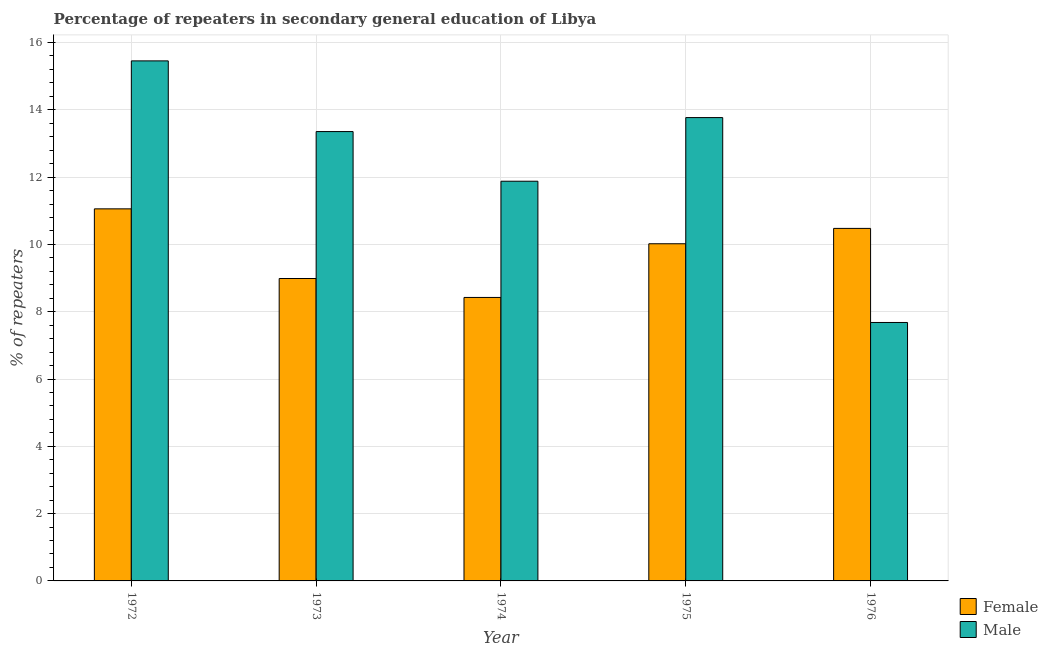Are the number of bars per tick equal to the number of legend labels?
Provide a succinct answer. Yes. Are the number of bars on each tick of the X-axis equal?
Offer a very short reply. Yes. How many bars are there on the 1st tick from the left?
Offer a very short reply. 2. How many bars are there on the 4th tick from the right?
Your answer should be compact. 2. What is the label of the 1st group of bars from the left?
Provide a short and direct response. 1972. What is the percentage of female repeaters in 1974?
Your answer should be compact. 8.42. Across all years, what is the maximum percentage of male repeaters?
Offer a very short reply. 15.45. Across all years, what is the minimum percentage of male repeaters?
Provide a short and direct response. 7.68. In which year was the percentage of male repeaters minimum?
Offer a terse response. 1976. What is the total percentage of male repeaters in the graph?
Keep it short and to the point. 62.13. What is the difference between the percentage of male repeaters in 1973 and that in 1974?
Make the answer very short. 1.48. What is the difference between the percentage of female repeaters in 1974 and the percentage of male repeaters in 1976?
Your answer should be compact. -2.05. What is the average percentage of female repeaters per year?
Your response must be concise. 9.79. In how many years, is the percentage of female repeaters greater than 12 %?
Offer a terse response. 0. What is the ratio of the percentage of female repeaters in 1973 to that in 1976?
Make the answer very short. 0.86. Is the percentage of male repeaters in 1973 less than that in 1976?
Provide a succinct answer. No. What is the difference between the highest and the second highest percentage of male repeaters?
Your response must be concise. 1.68. What is the difference between the highest and the lowest percentage of female repeaters?
Provide a short and direct response. 2.63. What does the 2nd bar from the right in 1975 represents?
Provide a succinct answer. Female. How many legend labels are there?
Give a very brief answer. 2. How are the legend labels stacked?
Provide a succinct answer. Vertical. What is the title of the graph?
Your answer should be compact. Percentage of repeaters in secondary general education of Libya. Does "GDP per capita" appear as one of the legend labels in the graph?
Your response must be concise. No. What is the label or title of the X-axis?
Make the answer very short. Year. What is the label or title of the Y-axis?
Your response must be concise. % of repeaters. What is the % of repeaters in Female in 1972?
Your answer should be very brief. 11.06. What is the % of repeaters of Male in 1972?
Give a very brief answer. 15.45. What is the % of repeaters in Female in 1973?
Offer a very short reply. 8.99. What is the % of repeaters in Male in 1973?
Ensure brevity in your answer.  13.35. What is the % of repeaters of Female in 1974?
Keep it short and to the point. 8.42. What is the % of repeaters in Male in 1974?
Your answer should be compact. 11.88. What is the % of repeaters of Female in 1975?
Provide a short and direct response. 10.02. What is the % of repeaters of Male in 1975?
Provide a succinct answer. 13.77. What is the % of repeaters in Female in 1976?
Provide a short and direct response. 10.48. What is the % of repeaters in Male in 1976?
Your response must be concise. 7.68. Across all years, what is the maximum % of repeaters in Female?
Make the answer very short. 11.06. Across all years, what is the maximum % of repeaters in Male?
Ensure brevity in your answer.  15.45. Across all years, what is the minimum % of repeaters of Female?
Provide a short and direct response. 8.42. Across all years, what is the minimum % of repeaters in Male?
Ensure brevity in your answer.  7.68. What is the total % of repeaters in Female in the graph?
Your answer should be very brief. 48.96. What is the total % of repeaters of Male in the graph?
Your answer should be compact. 62.13. What is the difference between the % of repeaters in Female in 1972 and that in 1973?
Ensure brevity in your answer.  2.07. What is the difference between the % of repeaters in Male in 1972 and that in 1973?
Give a very brief answer. 2.1. What is the difference between the % of repeaters in Female in 1972 and that in 1974?
Provide a short and direct response. 2.63. What is the difference between the % of repeaters of Male in 1972 and that in 1974?
Make the answer very short. 3.58. What is the difference between the % of repeaters in Female in 1972 and that in 1975?
Provide a short and direct response. 1.04. What is the difference between the % of repeaters of Male in 1972 and that in 1975?
Ensure brevity in your answer.  1.68. What is the difference between the % of repeaters in Female in 1972 and that in 1976?
Your answer should be very brief. 0.58. What is the difference between the % of repeaters of Male in 1972 and that in 1976?
Your response must be concise. 7.77. What is the difference between the % of repeaters in Female in 1973 and that in 1974?
Offer a very short reply. 0.56. What is the difference between the % of repeaters in Male in 1973 and that in 1974?
Offer a terse response. 1.48. What is the difference between the % of repeaters of Female in 1973 and that in 1975?
Make the answer very short. -1.03. What is the difference between the % of repeaters of Male in 1973 and that in 1975?
Your answer should be very brief. -0.42. What is the difference between the % of repeaters of Female in 1973 and that in 1976?
Your response must be concise. -1.49. What is the difference between the % of repeaters in Male in 1973 and that in 1976?
Your answer should be very brief. 5.67. What is the difference between the % of repeaters of Female in 1974 and that in 1975?
Make the answer very short. -1.6. What is the difference between the % of repeaters of Male in 1974 and that in 1975?
Offer a terse response. -1.89. What is the difference between the % of repeaters in Female in 1974 and that in 1976?
Ensure brevity in your answer.  -2.05. What is the difference between the % of repeaters of Male in 1974 and that in 1976?
Your answer should be very brief. 4.2. What is the difference between the % of repeaters of Female in 1975 and that in 1976?
Ensure brevity in your answer.  -0.46. What is the difference between the % of repeaters of Male in 1975 and that in 1976?
Your answer should be very brief. 6.09. What is the difference between the % of repeaters of Female in 1972 and the % of repeaters of Male in 1973?
Your answer should be very brief. -2.3. What is the difference between the % of repeaters in Female in 1972 and the % of repeaters in Male in 1974?
Ensure brevity in your answer.  -0.82. What is the difference between the % of repeaters in Female in 1972 and the % of repeaters in Male in 1975?
Offer a terse response. -2.71. What is the difference between the % of repeaters in Female in 1972 and the % of repeaters in Male in 1976?
Offer a terse response. 3.38. What is the difference between the % of repeaters of Female in 1973 and the % of repeaters of Male in 1974?
Provide a short and direct response. -2.89. What is the difference between the % of repeaters of Female in 1973 and the % of repeaters of Male in 1975?
Offer a very short reply. -4.78. What is the difference between the % of repeaters of Female in 1973 and the % of repeaters of Male in 1976?
Keep it short and to the point. 1.31. What is the difference between the % of repeaters of Female in 1974 and the % of repeaters of Male in 1975?
Your response must be concise. -5.34. What is the difference between the % of repeaters in Female in 1974 and the % of repeaters in Male in 1976?
Keep it short and to the point. 0.74. What is the difference between the % of repeaters in Female in 1975 and the % of repeaters in Male in 1976?
Offer a very short reply. 2.34. What is the average % of repeaters of Female per year?
Keep it short and to the point. 9.79. What is the average % of repeaters of Male per year?
Your answer should be very brief. 12.43. In the year 1972, what is the difference between the % of repeaters of Female and % of repeaters of Male?
Offer a terse response. -4.4. In the year 1973, what is the difference between the % of repeaters in Female and % of repeaters in Male?
Your response must be concise. -4.37. In the year 1974, what is the difference between the % of repeaters of Female and % of repeaters of Male?
Offer a terse response. -3.45. In the year 1975, what is the difference between the % of repeaters in Female and % of repeaters in Male?
Provide a succinct answer. -3.75. In the year 1976, what is the difference between the % of repeaters in Female and % of repeaters in Male?
Your answer should be compact. 2.8. What is the ratio of the % of repeaters of Female in 1972 to that in 1973?
Ensure brevity in your answer.  1.23. What is the ratio of the % of repeaters of Male in 1972 to that in 1973?
Your answer should be very brief. 1.16. What is the ratio of the % of repeaters of Female in 1972 to that in 1974?
Make the answer very short. 1.31. What is the ratio of the % of repeaters of Male in 1972 to that in 1974?
Your answer should be very brief. 1.3. What is the ratio of the % of repeaters in Female in 1972 to that in 1975?
Your answer should be compact. 1.1. What is the ratio of the % of repeaters in Male in 1972 to that in 1975?
Provide a succinct answer. 1.12. What is the ratio of the % of repeaters in Female in 1972 to that in 1976?
Your response must be concise. 1.06. What is the ratio of the % of repeaters in Male in 1972 to that in 1976?
Ensure brevity in your answer.  2.01. What is the ratio of the % of repeaters in Female in 1973 to that in 1974?
Provide a short and direct response. 1.07. What is the ratio of the % of repeaters in Male in 1973 to that in 1974?
Your response must be concise. 1.12. What is the ratio of the % of repeaters in Female in 1973 to that in 1975?
Your answer should be very brief. 0.9. What is the ratio of the % of repeaters of Male in 1973 to that in 1975?
Ensure brevity in your answer.  0.97. What is the ratio of the % of repeaters in Female in 1973 to that in 1976?
Make the answer very short. 0.86. What is the ratio of the % of repeaters in Male in 1973 to that in 1976?
Provide a short and direct response. 1.74. What is the ratio of the % of repeaters of Female in 1974 to that in 1975?
Offer a terse response. 0.84. What is the ratio of the % of repeaters in Male in 1974 to that in 1975?
Your response must be concise. 0.86. What is the ratio of the % of repeaters in Female in 1974 to that in 1976?
Your answer should be compact. 0.8. What is the ratio of the % of repeaters of Male in 1974 to that in 1976?
Make the answer very short. 1.55. What is the ratio of the % of repeaters in Female in 1975 to that in 1976?
Ensure brevity in your answer.  0.96. What is the ratio of the % of repeaters of Male in 1975 to that in 1976?
Provide a succinct answer. 1.79. What is the difference between the highest and the second highest % of repeaters in Female?
Offer a terse response. 0.58. What is the difference between the highest and the second highest % of repeaters of Male?
Give a very brief answer. 1.68. What is the difference between the highest and the lowest % of repeaters of Female?
Make the answer very short. 2.63. What is the difference between the highest and the lowest % of repeaters in Male?
Provide a short and direct response. 7.77. 